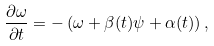Convert formula to latex. <formula><loc_0><loc_0><loc_500><loc_500>\frac { \partial { \omega } } { \partial t } = - \left ( { \omega } + \beta ( t ) \psi + \alpha ( t ) \right ) ,</formula> 